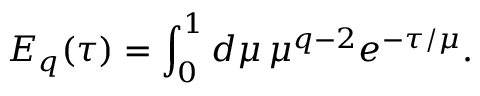<formula> <loc_0><loc_0><loc_500><loc_500>E _ { q } ( \tau ) = \int _ { 0 } ^ { 1 } d \mu \, \mu ^ { q - 2 } e ^ { - \tau / \mu } .</formula> 